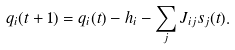Convert formula to latex. <formula><loc_0><loc_0><loc_500><loc_500>q _ { i } ( t + 1 ) = q _ { i } ( t ) - h _ { i } - \sum _ { j } J _ { i j } s _ { j } ( t ) .</formula> 